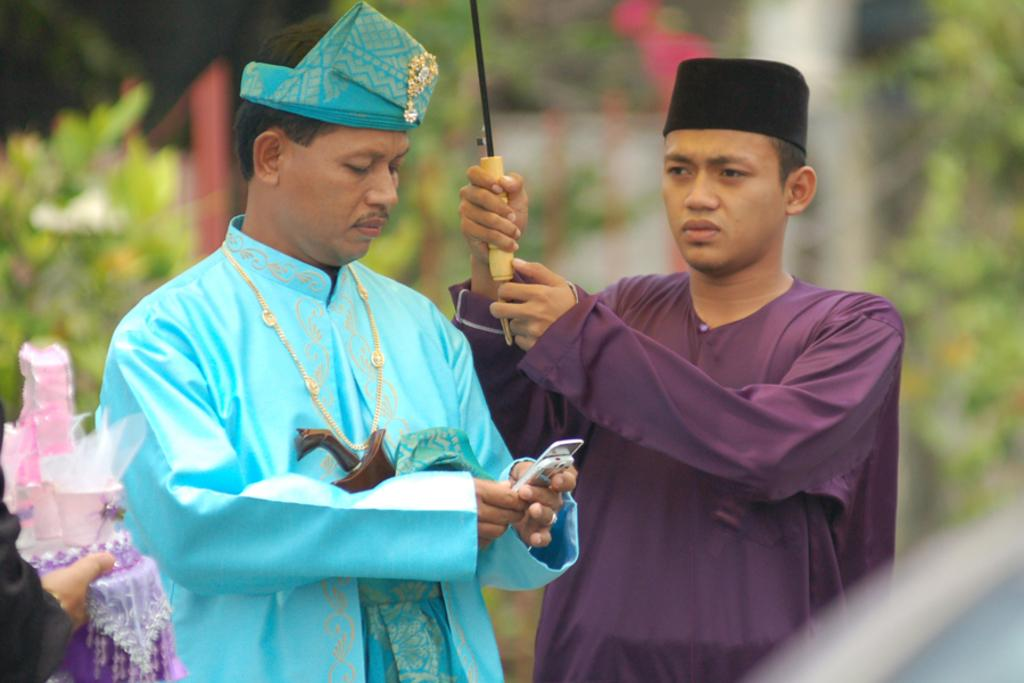How many people are in the image? There are two people in the image. What are the people doing in the image? The people are standing in the image. What are the people holding in the image? The people are holding something in the image. What colors are the dresses worn by the people? One person is wearing a blue dress, and the other person is wearing a purple dress. What can be seen in the background of the image? There are trees visible in the background of the image. How would you describe the background of the image? The background is blurred in the image. How many toes can be seen on the people's feet in the image? There is no information about the people's feet or toes in the image, so it cannot be determined. 